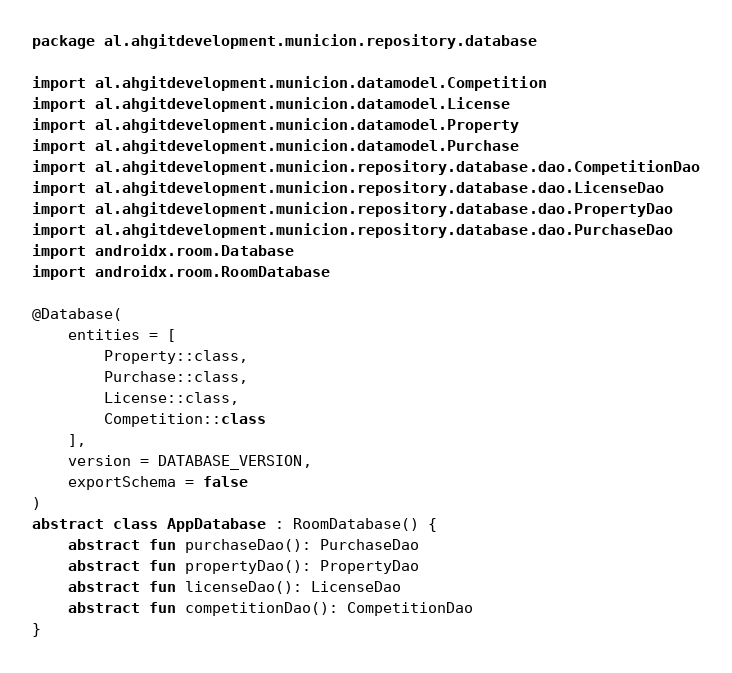<code> <loc_0><loc_0><loc_500><loc_500><_Kotlin_>package al.ahgitdevelopment.municion.repository.database

import al.ahgitdevelopment.municion.datamodel.Competition
import al.ahgitdevelopment.municion.datamodel.License
import al.ahgitdevelopment.municion.datamodel.Property
import al.ahgitdevelopment.municion.datamodel.Purchase
import al.ahgitdevelopment.municion.repository.database.dao.CompetitionDao
import al.ahgitdevelopment.municion.repository.database.dao.LicenseDao
import al.ahgitdevelopment.municion.repository.database.dao.PropertyDao
import al.ahgitdevelopment.municion.repository.database.dao.PurchaseDao
import androidx.room.Database
import androidx.room.RoomDatabase

@Database(
    entities = [
        Property::class,
        Purchase::class,
        License::class,
        Competition::class
    ],
    version = DATABASE_VERSION,
    exportSchema = false
)
abstract class AppDatabase : RoomDatabase() {
    abstract fun purchaseDao(): PurchaseDao
    abstract fun propertyDao(): PropertyDao
    abstract fun licenseDao(): LicenseDao
    abstract fun competitionDao(): CompetitionDao
}
</code> 